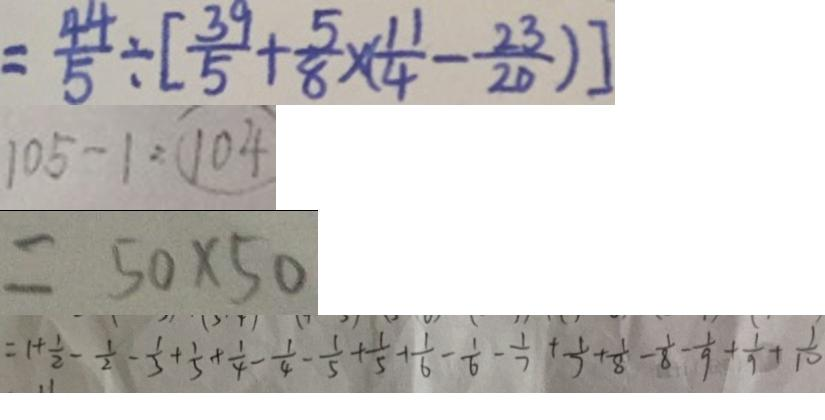Convert formula to latex. <formula><loc_0><loc_0><loc_500><loc_500>= \frac { 4 4 } { 5 } \div [ \frac { 3 9 } { 5 } + \frac { 5 } { 8 } \times ( \frac { 1 1 } { 4 } - \frac { 2 3 } { 2 0 } ) ] 
 1 0 5 - 1 = 1 0 4 
 = 5 0 \times 5 0 
 = 1 + \frac { 1 } { 2 } - \frac { 1 } { 2 } - \frac { 1 } { 3 } + \frac { 1 } { 3 } + \frac { 1 } { 4 } - \frac { 1 } { 4 } - \frac { 1 } { 5 } + \frac { 1 } { 5 } + \frac { 1 } { 6 } - \frac { 1 } { 6 } - \frac { 1 } { 7 } + \frac { 1 } { 7 } + \frac { 1 } { 8 } - \frac { 1 } { 8 } - \frac { 1 } { 9 } + \frac { 1 } { 9 } + \frac { 1 } { 1 0 }</formula> 